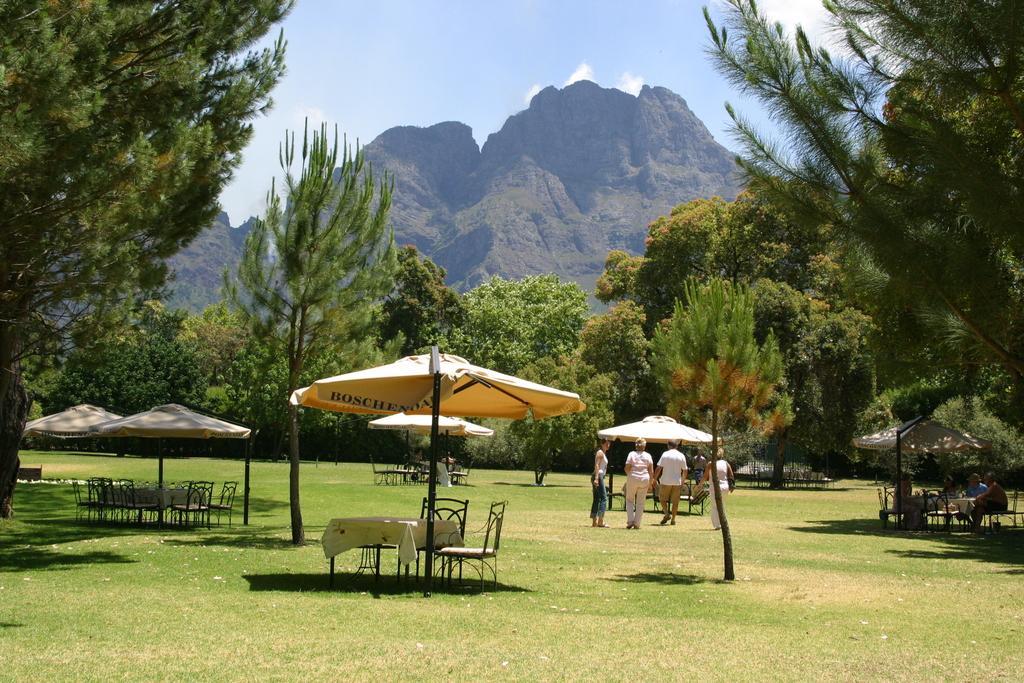Describe this image in one or two sentences. In the image we can see there are people walking, standing and some of them are sitting. They are wearing clothes, this is grass, umbrella, chairs, table, trees, mountains and a cloudy pale blue sky. 